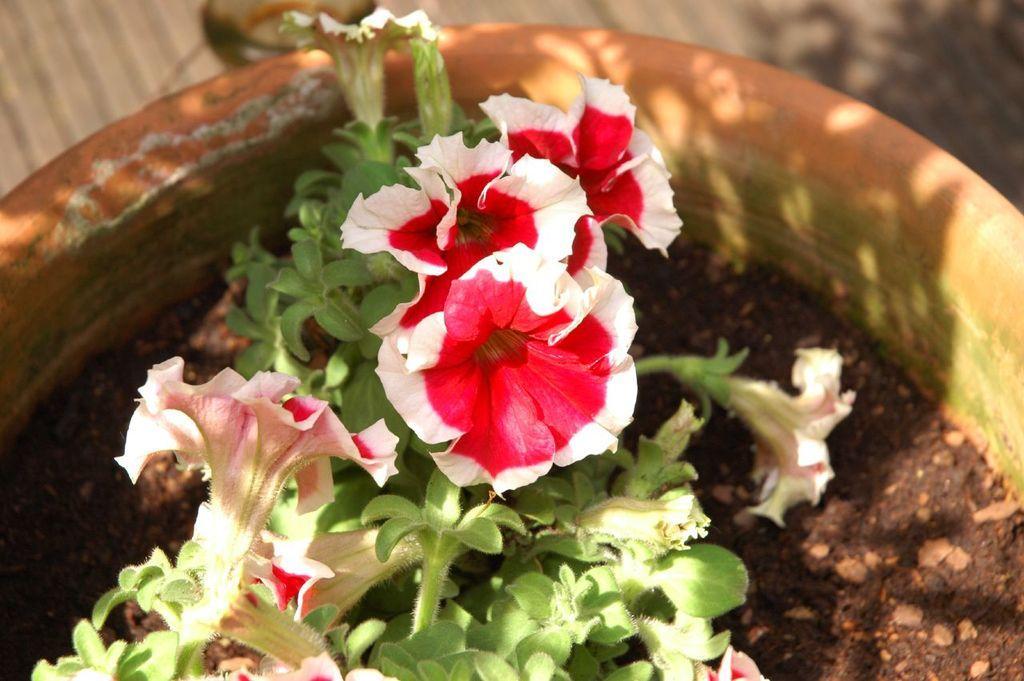Please provide a concise description of this image. In this image we can see a flower to a house plant. 